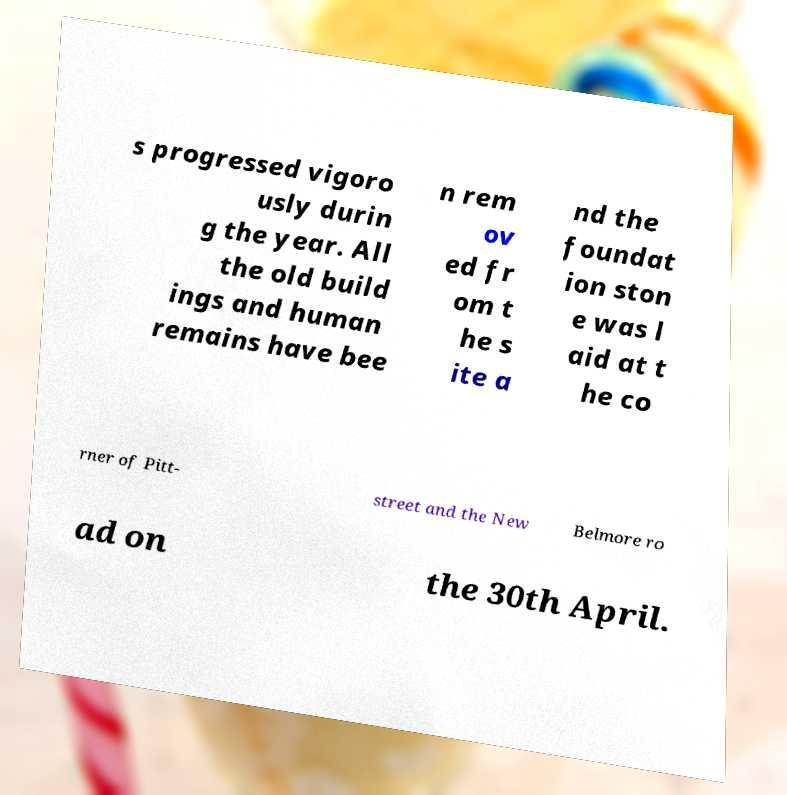Please read and relay the text visible in this image. What does it say? s progressed vigoro usly durin g the year. All the old build ings and human remains have bee n rem ov ed fr om t he s ite a nd the foundat ion ston e was l aid at t he co rner of Pitt- street and the New Belmore ro ad on the 30th April. 